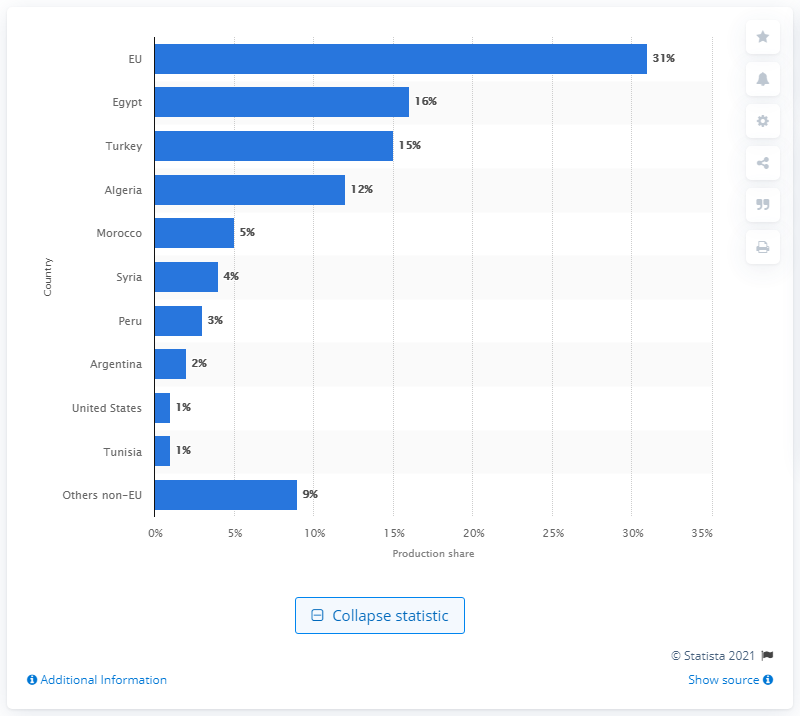Give some essential details in this illustration. In 2017/2018, Egypt was the country with the largest production share of table olives. 